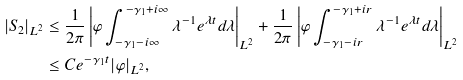Convert formula to latex. <formula><loc_0><loc_0><loc_500><loc_500>| S _ { 2 } | _ { L ^ { 2 } } & \leq \frac { 1 } { 2 \pi } \left | \varphi \int _ { - \gamma _ { 1 } - i \infty } ^ { - \gamma _ { 1 } + i \infty } \lambda ^ { - 1 } e ^ { \lambda t } d \lambda \right | _ { L ^ { 2 } } + \frac { 1 } { 2 \pi } \left | \varphi \int _ { - \gamma _ { 1 } - i r } ^ { - \gamma _ { 1 } + i r } \lambda ^ { - 1 } e ^ { \lambda t } d \lambda \right | _ { L ^ { 2 } } \\ & \leq C e ^ { - \gamma _ { 1 } t } | \varphi | _ { L ^ { 2 } } ,</formula> 